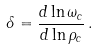<formula> <loc_0><loc_0><loc_500><loc_500>\delta = \frac { d \ln \omega _ { c } } { d \ln \rho _ { c } } \, .</formula> 